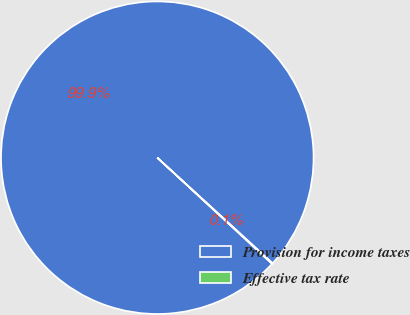Convert chart to OTSL. <chart><loc_0><loc_0><loc_500><loc_500><pie_chart><fcel>Provision for income taxes<fcel>Effective tax rate<nl><fcel>99.92%<fcel>0.08%<nl></chart> 